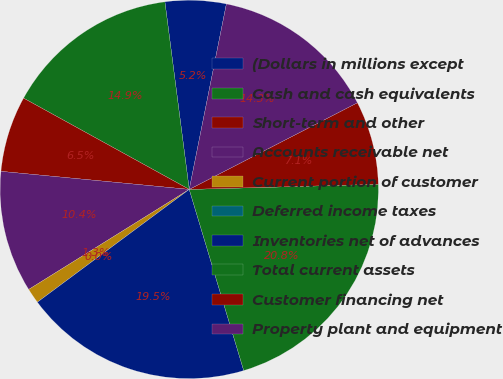Convert chart. <chart><loc_0><loc_0><loc_500><loc_500><pie_chart><fcel>(Dollars in millions except<fcel>Cash and cash equivalents<fcel>Short-term and other<fcel>Accounts receivable net<fcel>Current portion of customer<fcel>Deferred income taxes<fcel>Inventories net of advances<fcel>Total current assets<fcel>Customer financing net<fcel>Property plant and equipment<nl><fcel>5.2%<fcel>14.93%<fcel>6.49%<fcel>10.39%<fcel>1.3%<fcel>0.0%<fcel>19.48%<fcel>20.78%<fcel>7.14%<fcel>14.28%<nl></chart> 